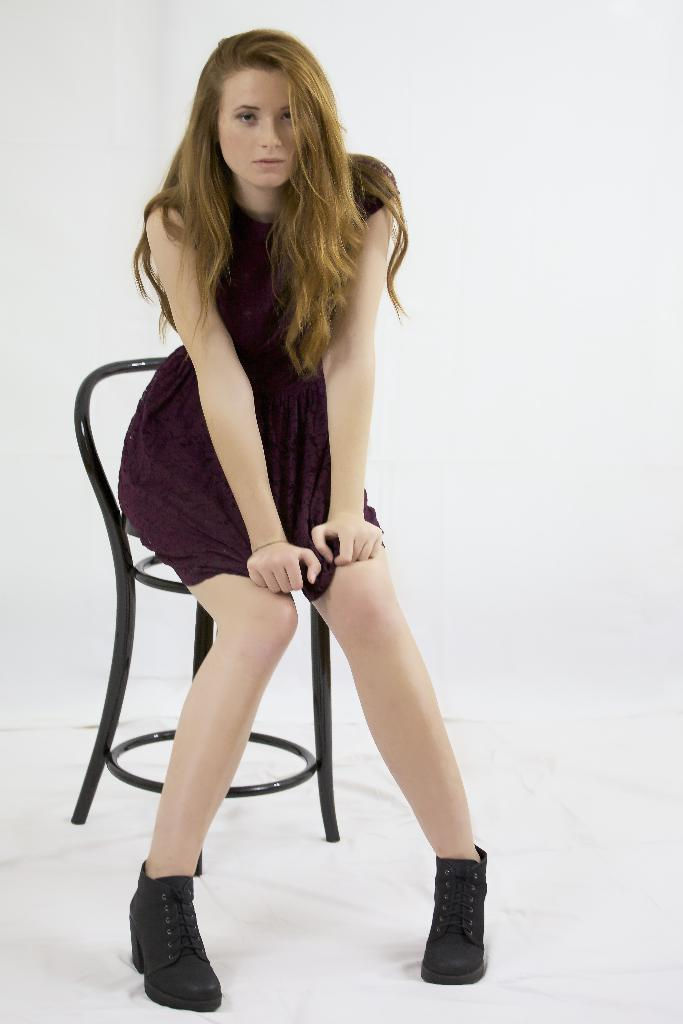Who is the main subject in the image? There is a lady in the image. What is the lady doing in the image? The lady is sitting on a chair. What is the lady's idea about the upcoming town festival in the image? There is no information about a town festival or the lady's ideas in the image. 